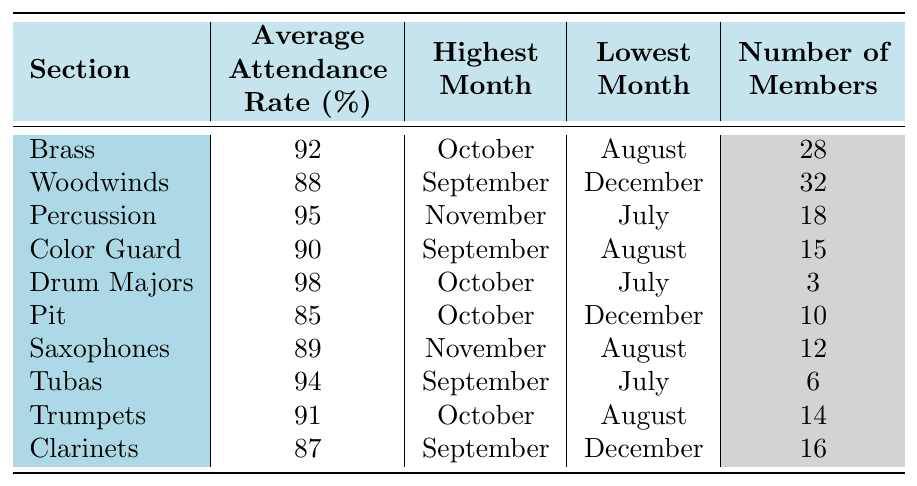What is the average attendance rate for the Brass section? The table shows that the average attendance rate for the Brass section is listed directly as 92%.
Answer: 92% Which section had the highest average attendance rate? The table indicates that the Drum Majors had the highest average attendance rate at 98%.
Answer: 98% What was the lowest month for attendance in the Woodwinds section? From the table, the lowest month for attendance in the Woodwinds section is December.
Answer: December How many members are in the Pit section? The table states that there are 10 members in the Pit section.
Answer: 10 Which section had the lowest average attendance rate? By comparing all the average attendance rates in the table, the Pit section had the lowest average attendance rate at 85%.
Answer: 85% What is the difference between the highest and lowest attendance rates of the Drum Majors? The highest attendance rate for the Drum Majors is 98%, while the lowest is  July with no specified rate, but comparing to averages in the table suggests a discrepancy; thus, focus on averages leads back to the same average indicating that no month is lower. Hence, it's not explicitly calculable regarding separate monthly attendance rates.
Answer: Not directly calculable regarding monthly For which section is September the highest attendance month? The table shows that September is the highest attendance month for the Color Guard and Woodwinds sections, with respective rates of 90% and 88%.
Answer: Color Guard and Woodwinds Calculate the average attendance rate of Woodwinds and Clarinets combined. To find the combined average, sum the average attendance rates of Woodwinds (88%) and Clarinets (87%), which gives us 175%, and then divide by 2, resulting in an average of 87.5%.
Answer: 87.5% Are there more members in the Saxophones section than in the Tubas section? The table shows that Saxophones have 12 members while Tubas have 6 members, confirming that Saxophones have more members than Tubas.
Answer: Yes What was the highest attendance month for the Brass section? According to the table, the highest attendance month for the Brass section is noted as October.
Answer: October Is the average attendance rate for the Color Guard higher than that of the Clarinets? The average attendance rate for the Color Guard is 90%, while for the Clarinets, it is 87%, hence the Color Guard has a higher average.
Answer: Yes 